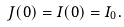<formula> <loc_0><loc_0><loc_500><loc_500>J ( 0 ) = I ( 0 ) = I _ { 0 } .</formula> 